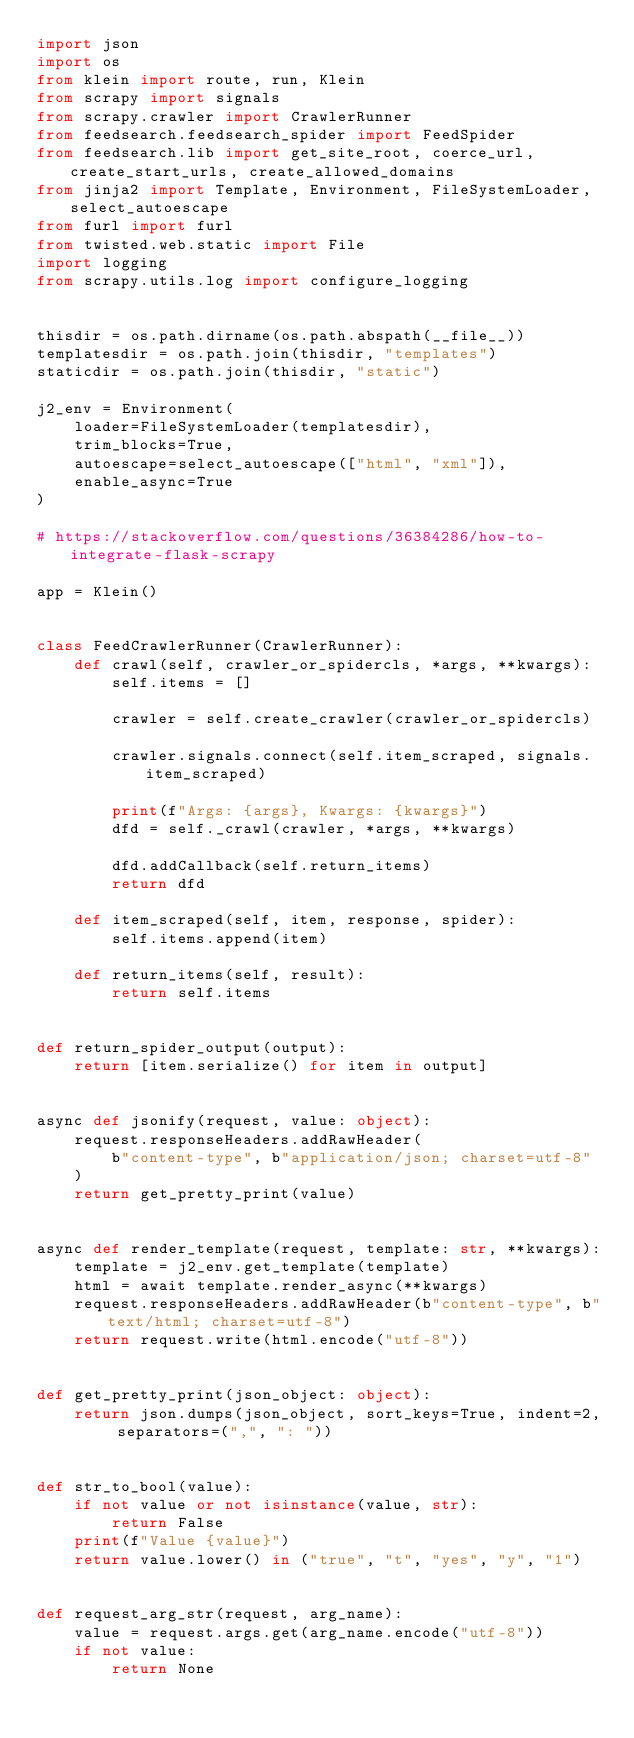Convert code to text. <code><loc_0><loc_0><loc_500><loc_500><_Python_>import json
import os
from klein import route, run, Klein
from scrapy import signals
from scrapy.crawler import CrawlerRunner
from feedsearch.feedsearch_spider import FeedSpider
from feedsearch.lib import get_site_root, coerce_url, create_start_urls, create_allowed_domains
from jinja2 import Template, Environment, FileSystemLoader, select_autoescape
from furl import furl
from twisted.web.static import File
import logging
from scrapy.utils.log import configure_logging


thisdir = os.path.dirname(os.path.abspath(__file__))
templatesdir = os.path.join(thisdir, "templates")
staticdir = os.path.join(thisdir, "static")

j2_env = Environment(
    loader=FileSystemLoader(templatesdir),
    trim_blocks=True,
    autoescape=select_autoescape(["html", "xml"]),
    enable_async=True
)

# https://stackoverflow.com/questions/36384286/how-to-integrate-flask-scrapy

app = Klein()


class FeedCrawlerRunner(CrawlerRunner):
    def crawl(self, crawler_or_spidercls, *args, **kwargs):
        self.items = []

        crawler = self.create_crawler(crawler_or_spidercls)

        crawler.signals.connect(self.item_scraped, signals.item_scraped)

        print(f"Args: {args}, Kwargs: {kwargs}")
        dfd = self._crawl(crawler, *args, **kwargs)

        dfd.addCallback(self.return_items)
        return dfd

    def item_scraped(self, item, response, spider):
        self.items.append(item)

    def return_items(self, result):
        return self.items


def return_spider_output(output):
    return [item.serialize() for item in output]


async def jsonify(request, value: object):
    request.responseHeaders.addRawHeader(
        b"content-type", b"application/json; charset=utf-8"
    )
    return get_pretty_print(value)


async def render_template(request, template: str, **kwargs):
    template = j2_env.get_template(template)
    html = await template.render_async(**kwargs)
    request.responseHeaders.addRawHeader(b"content-type", b"text/html; charset=utf-8")
    return request.write(html.encode("utf-8"))


def get_pretty_print(json_object: object):
    return json.dumps(json_object, sort_keys=True, indent=2, separators=(",", ": "))


def str_to_bool(value):
    if not value or not isinstance(value, str):
        return False
    print(f"Value {value}")
    return value.lower() in ("true", "t", "yes", "y", "1")


def request_arg_str(request, arg_name):
    value = request.args.get(arg_name.encode("utf-8"))
    if not value:
        return None</code> 